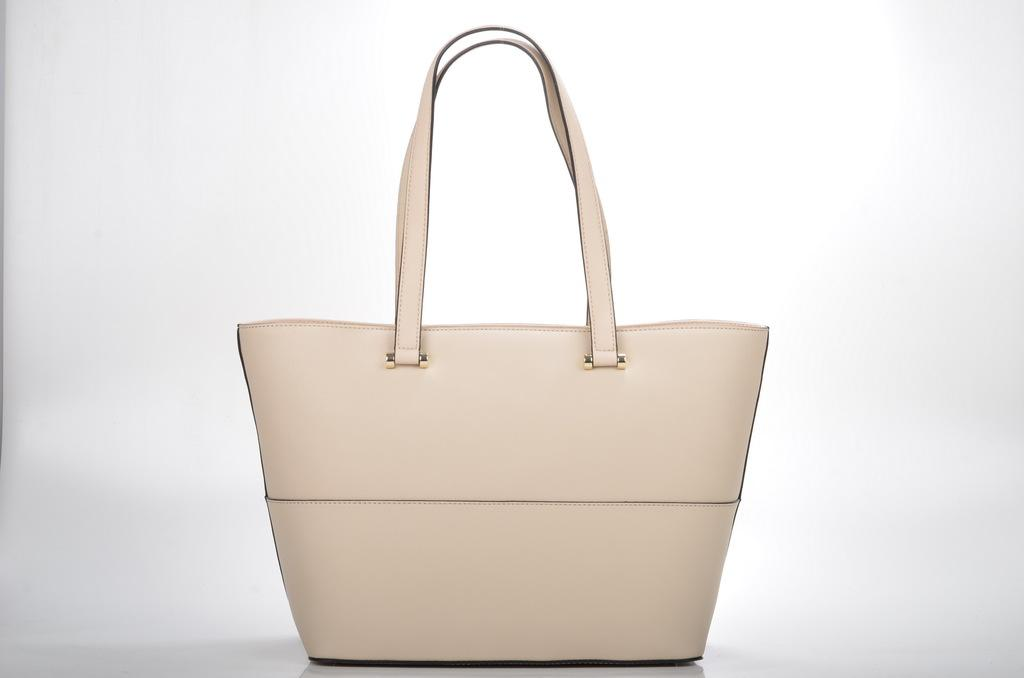What object can be seen in the image? There is a bag in the image. What is the color of the bag? The bag is cream in color. What type of screw is used to fasten the apparel in the image? There is no screw or apparel present in the image; it only features a bag. What is the size of the tub in the image? There is no tub present in the image. 